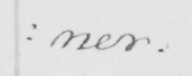What does this handwritten line say? : ner . 